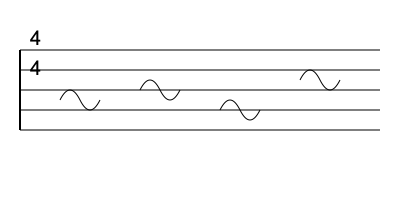In this sheet music excerpt from Mary Chapin Carpenter's "Passionate Kisses," what is the time signature? To determine the time signature in sheet music, we need to follow these steps:

1. Locate the time signature at the beginning of the staff. In this case, we can see two numbers stacked vertically at the left side of the staff.

2. Identify the top number: The top number tells us how many beats are in each measure. Here, we see a 4 on top.

3. Identify the bottom number: The bottom number indicates which note value gets one beat. In this case, we see a 4 on the bottom, which represents a quarter note.

4. Interpret the time signature: A 4 on top and a 4 on bottom means there are 4 quarter notes (or their equivalent) in each measure.

5. Confirm with the music: We can see that each measure contains notes that add up to 4 quarter notes, which is consistent with the time signature.

Therefore, the time signature for this excerpt from "Passionate Kisses" is 4/4, also known as common time.
Answer: 4/4 